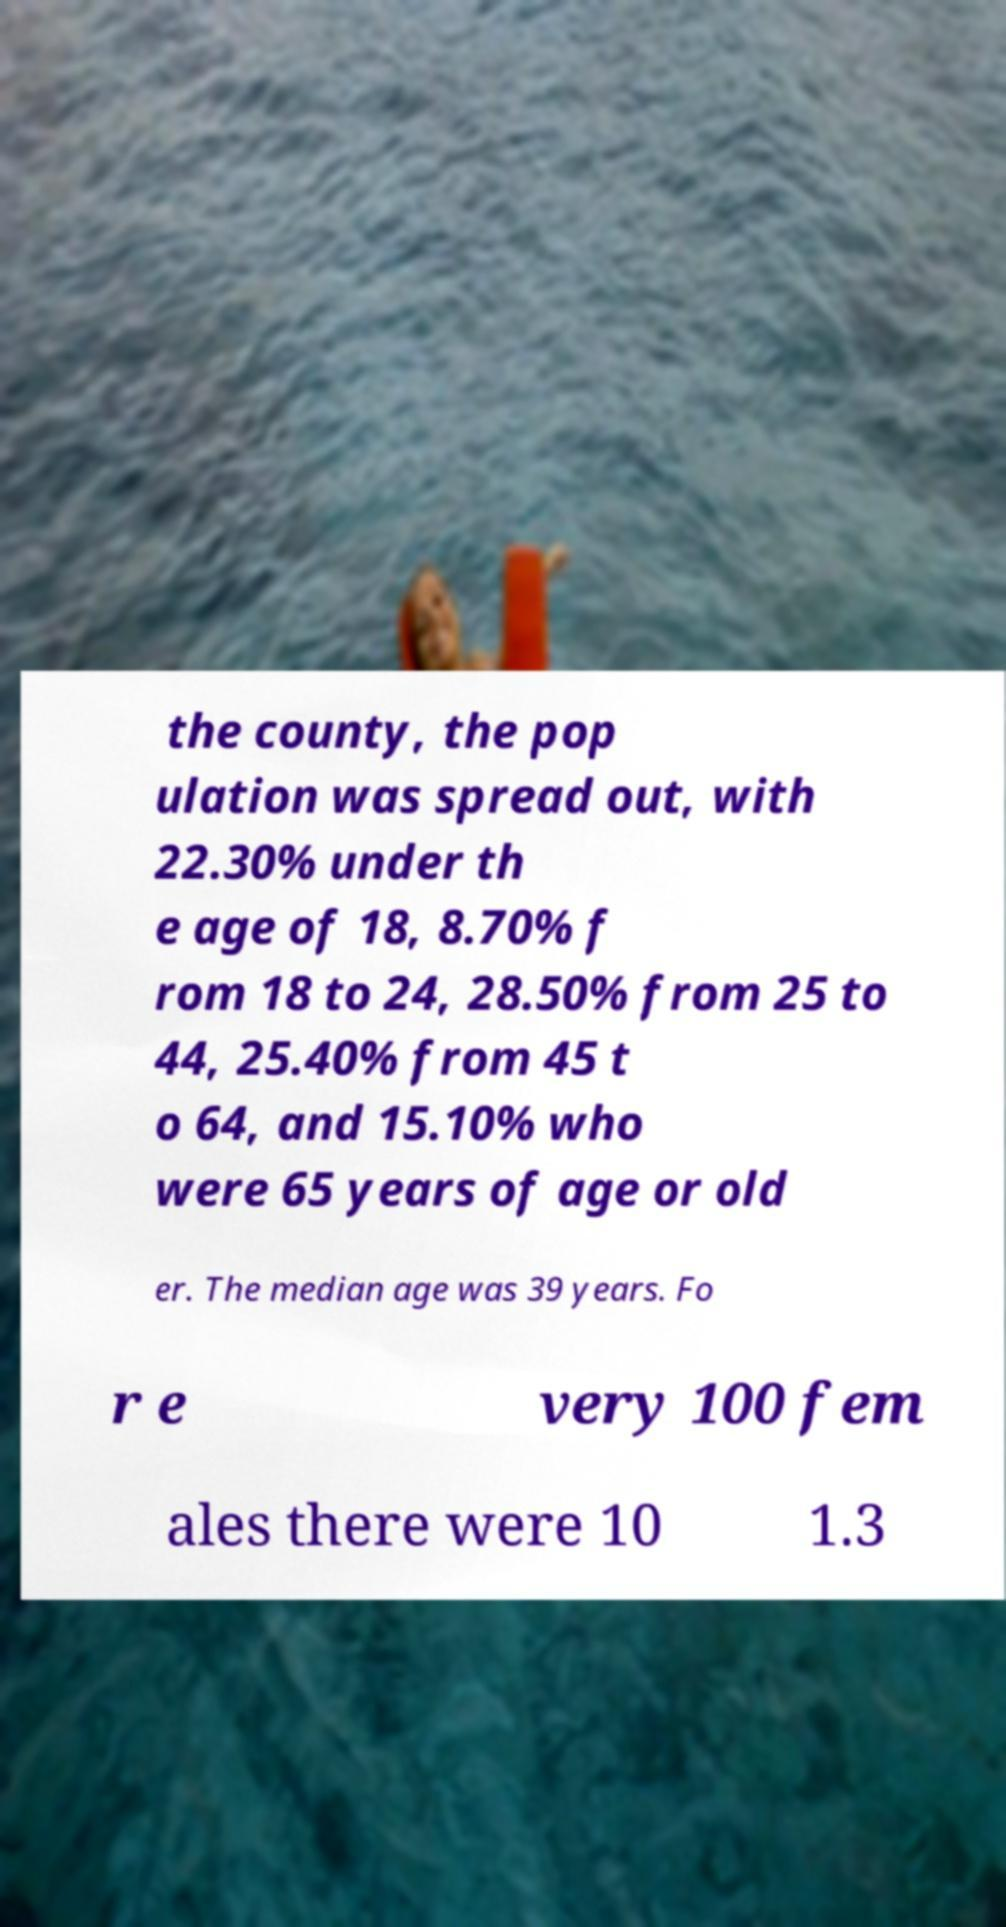Please read and relay the text visible in this image. What does it say? the county, the pop ulation was spread out, with 22.30% under th e age of 18, 8.70% f rom 18 to 24, 28.50% from 25 to 44, 25.40% from 45 t o 64, and 15.10% who were 65 years of age or old er. The median age was 39 years. Fo r e very 100 fem ales there were 10 1.3 